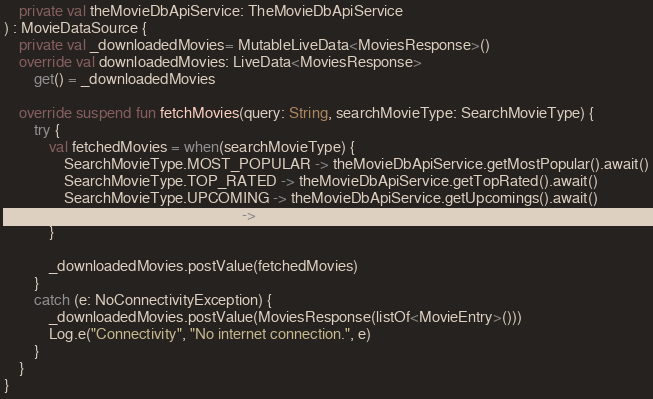<code> <loc_0><loc_0><loc_500><loc_500><_Kotlin_>    private val theMovieDbApiService: TheMovieDbApiService
) : MovieDataSource {
    private val _downloadedMovies= MutableLiveData<MoviesResponse>()
    override val downloadedMovies: LiveData<MoviesResponse>
        get() = _downloadedMovies

    override suspend fun fetchMovies(query: String, searchMovieType: SearchMovieType) {
        try {
            val fetchedMovies = when(searchMovieType) {
                SearchMovieType.MOST_POPULAR -> theMovieDbApiService.getMostPopular().await()
                SearchMovieType.TOP_RATED -> theMovieDbApiService.getTopRated().await()
                SearchMovieType.UPCOMING -> theMovieDbApiService.getUpcomings().await()
                SearchMovieType.FILTER -> theMovieDbApiService.getMovies(query).await()
            }

            _downloadedMovies.postValue(fetchedMovies)
        }
        catch (e: NoConnectivityException) {
            _downloadedMovies.postValue(MoviesResponse(listOf<MovieEntry>()))
            Log.e("Connectivity", "No internet connection.", e)
        }
    }
}</code> 